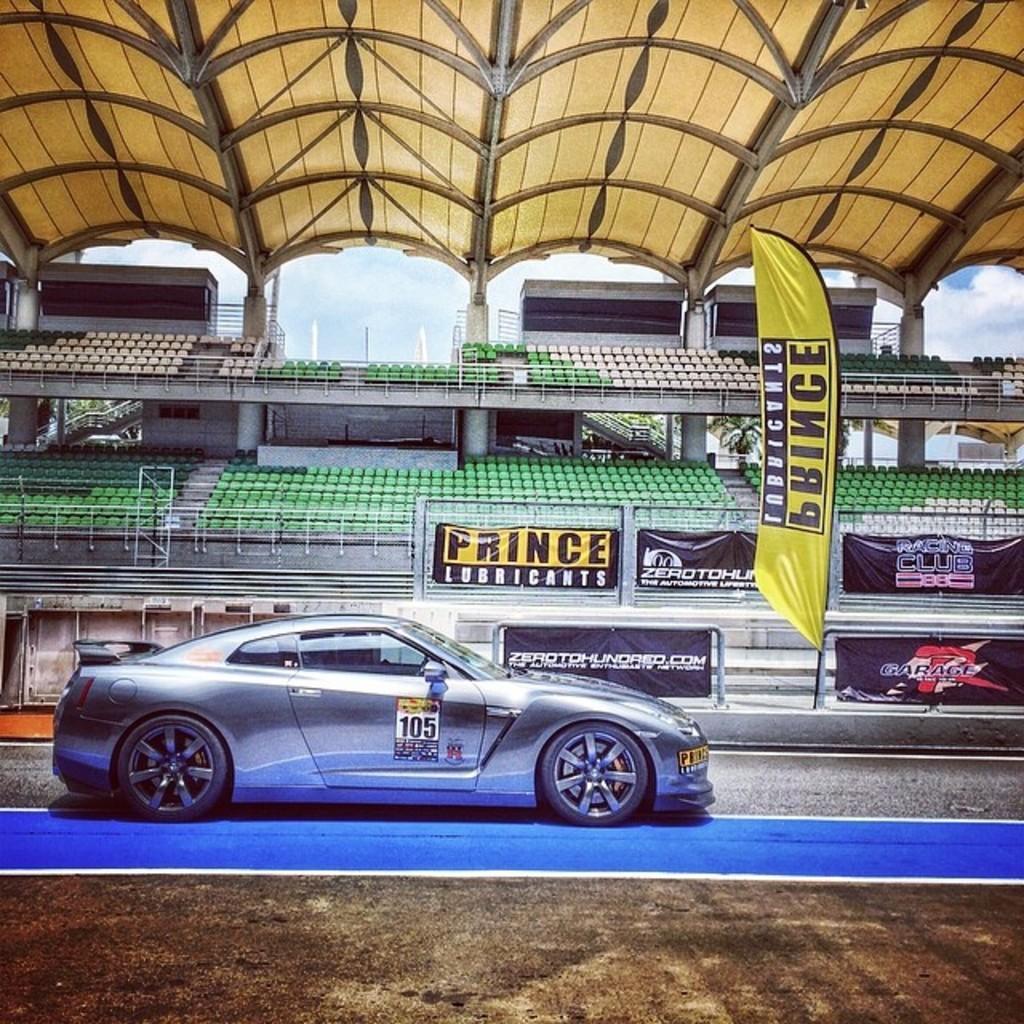How would you summarize this image in a sentence or two? In this image in the center there is one car, and in the background there are some seats, railing, posters, boards, poles and some chairs. At the bottom there is walkway, at the top there is ceiling and some poles. 